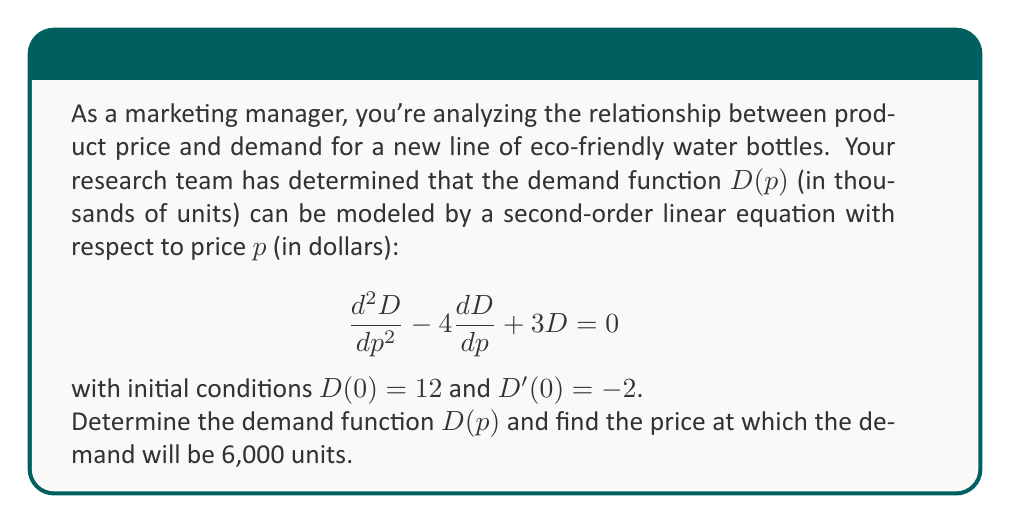Solve this math problem. To solve this problem, we'll follow these steps:

1) The general solution for a second-order linear equation with constant coefficients $ay'' + by' + cy = 0$ is of the form $y = C_1e^{r_1x} + C_2e^{r_2x}$, where $r_1$ and $r_2$ are roots of the characteristic equation $ar^2 + br + c = 0$.

2) In our case, the characteristic equation is $r^2 - 4r + 3 = 0$.

3) Solving this equation:
   $(r - 3)(r - 1) = 0$
   $r_1 = 3$ and $r_2 = 1$

4) Therefore, the general solution is:
   $D(p) = C_1e^{3p} + C_2e^p$

5) Using the initial conditions:
   $D(0) = 12$, so $C_1 + C_2 = 12$
   $D'(0) = -2$, so $3C_1 + C_2 = -2$

6) Solving these equations:
   $C_1 = -7$ and $C_2 = 19$

7) Thus, the demand function is:
   $D(p) = -7e^{3p} + 19e^p$

8) To find the price at which demand is 6,000 units (6 in our scale):
   $6 = -7e^{3p} + 19e^p$

9) This equation can't be solved algebraically. We need to use numerical methods or graphing to find $p \approx 0.7439$.
Answer: The demand function is $D(p) = -7e^{3p} + 19e^p$, and the price at which demand will be 6,000 units is approximately $0.7439$ dollars. 